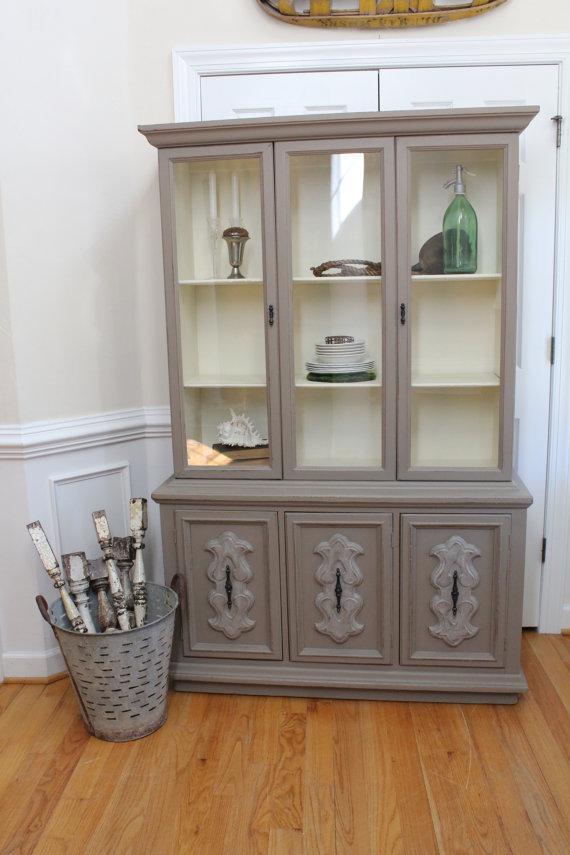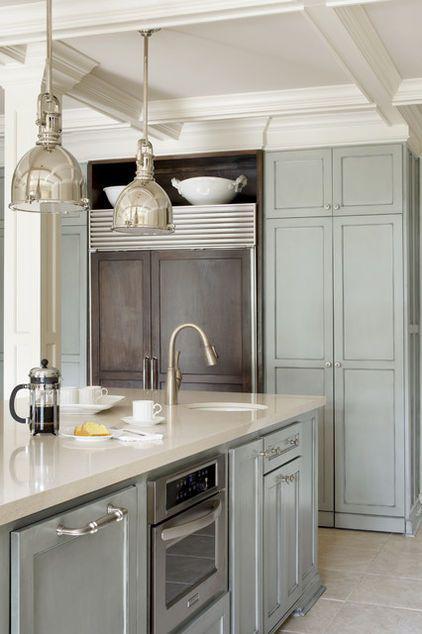The first image is the image on the left, the second image is the image on the right. Examine the images to the left and right. Is the description "One cabinet has a white exterior and a front that is not flat, with curving drawers under the display hutch top." accurate? Answer yes or no. No. The first image is the image on the left, the second image is the image on the right. Assess this claim about the two images: "The cabinet in the image on the right is not a square shape.". Correct or not? Answer yes or no. No. 